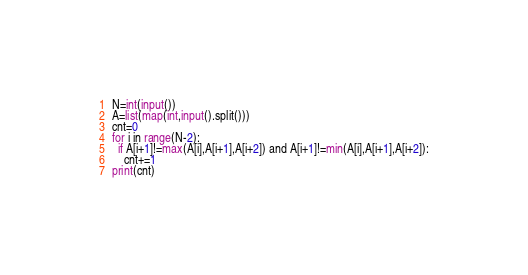<code> <loc_0><loc_0><loc_500><loc_500><_Python_>N=int(input())
A=list(map(int,input().split()))
cnt=0
for i in range(N-2):
  if A[i+1]!=max(A[i],A[i+1],A[i+2]) and A[i+1]!=min(A[i],A[i+1],A[i+2]):
    cnt+=1
print(cnt)</code> 